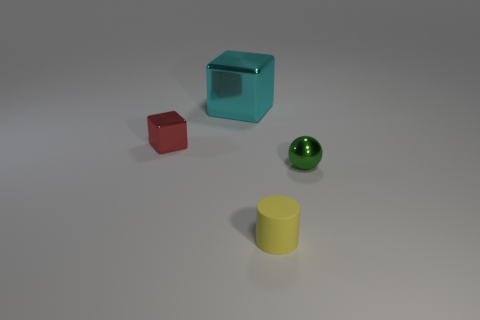Is there any other thing that has the same size as the cyan metal object?
Your answer should be compact. No. Are there any other things that are the same shape as the tiny yellow rubber object?
Your answer should be very brief. No. There is a small object that is in front of the tiny metallic object to the right of the cube to the right of the small red shiny block; what is it made of?
Offer a terse response. Rubber. Is there another shiny block of the same size as the red cube?
Ensure brevity in your answer.  No. There is a metal cube that is behind the shiny thing to the left of the large metal cube; what is its color?
Ensure brevity in your answer.  Cyan. What number of green spheres are there?
Ensure brevity in your answer.  1. Are there fewer tiny spheres that are in front of the yellow object than small yellow rubber things that are to the left of the tiny green thing?
Keep it short and to the point. Yes. What is the color of the metal sphere?
Keep it short and to the point. Green. Are there any yellow matte cylinders in front of the green metal sphere?
Your answer should be compact. Yes. Are there an equal number of small objects that are right of the small cylinder and tiny spheres that are left of the cyan cube?
Make the answer very short. No. 